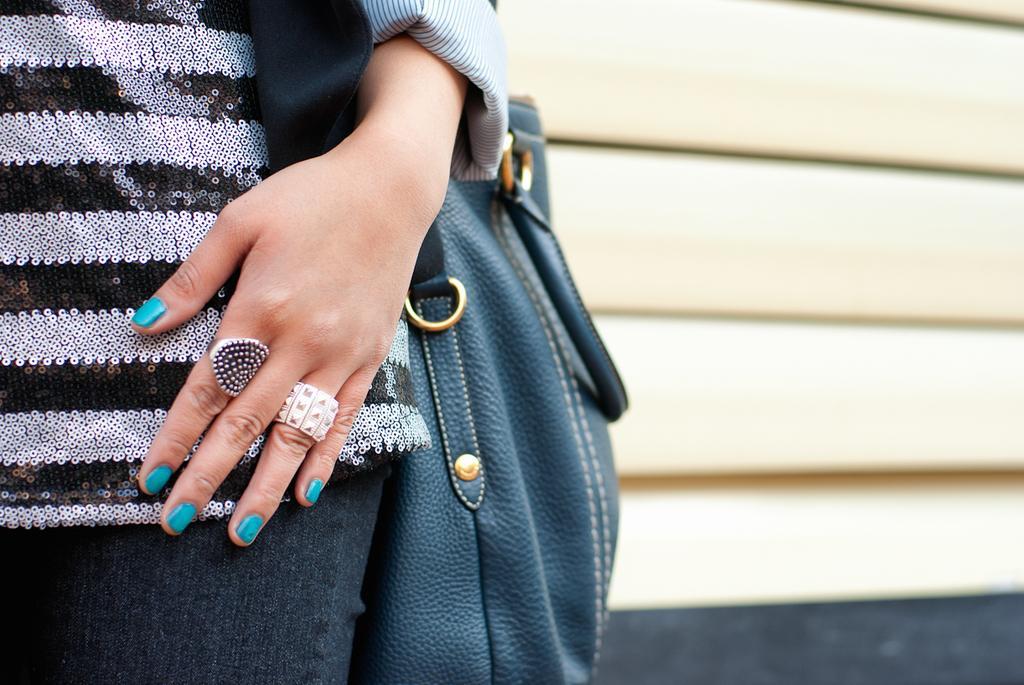How would you summarize this image in a sentence or two? In this picture we can see a woman wearing a handbag. We can see green colour nail paint on her nails. 